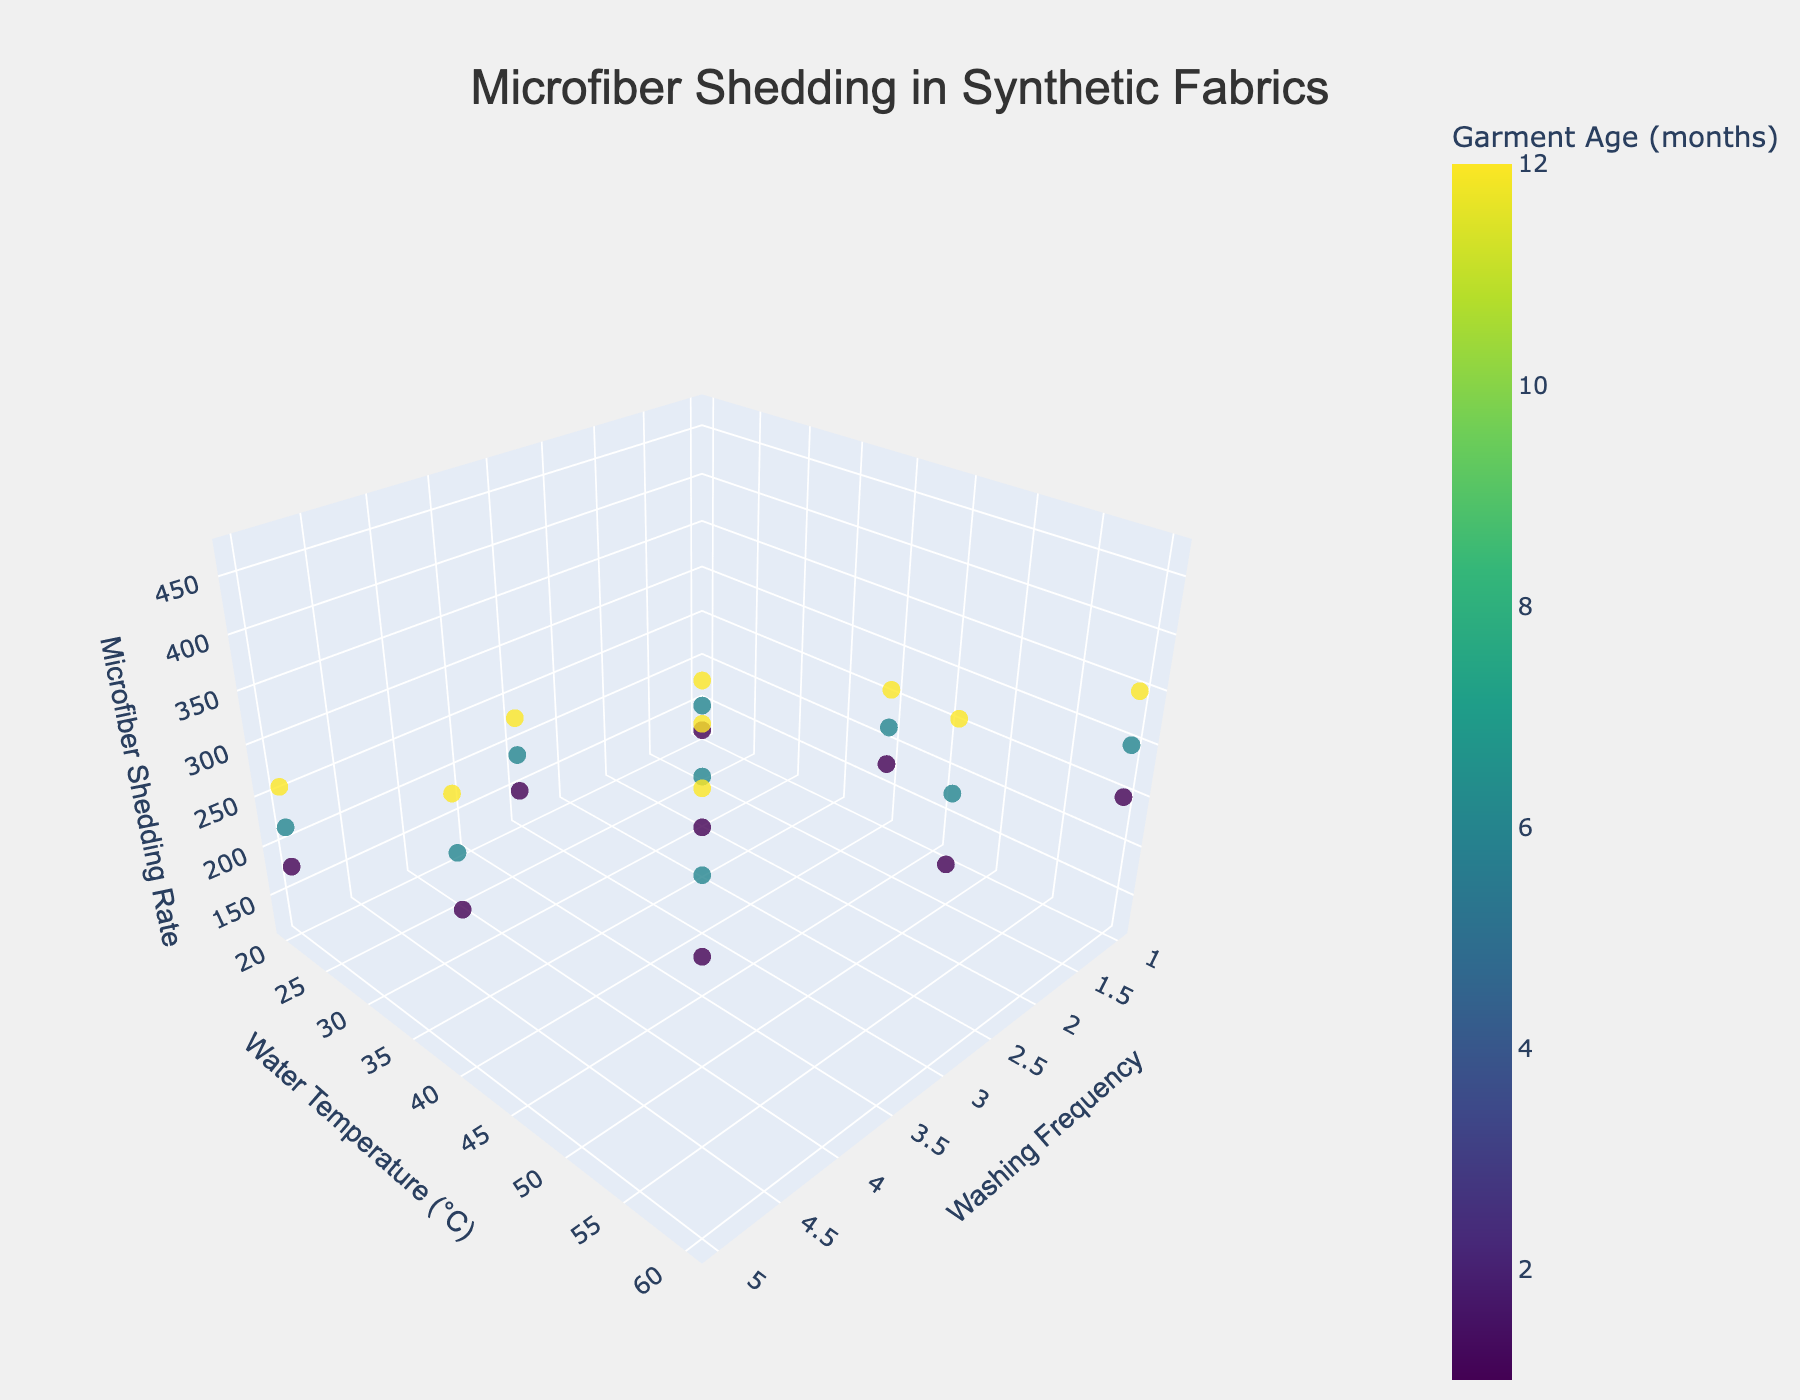What is the title of the figure? Look at the top center of the figure where the title is displayed.
Answer: Microfiber Shedding in Synthetic Fabrics What are the three variables plotted on each axis? The variables are labeled at the tips of the axes. The x-axis is washing frequency, the y-axis is water temperature, and the z-axis is microfiber shedding rate.
Answer: Washing frequency, Water temperature, Microfiber shedding rate How does microfiber shedding rate change with increasing washing frequency at a water temperature of 20°C for a 1-month-old garment? Look at the points along the line where the water temperature is 20°C and garment age is 1 month. Observe the z-values (microfiber shedding rate) at different washing frequencies.
Answer: Increases Which garment age has the highest microfiber shedding rate and what is that rate? Check the colorbar to find the color representing the highest microfiber shedding rate, then identify the corresponding garment age and shedding rate.
Answer: 12 months, 470 fibers How does the microfiber shedding rate for a washing frequency of 1 generally compare at different garment ages? Observe the points where the washing frequency is 1 and compare the z-values (microfiber shedding rates) across different garment ages.
Answer: Increases with garment age What is the difference in the microfiber shedding rate between garments washed at 60°C and 20°C after 3 washes when the garments are 6 months old? Identify the points for 3 washes at 60°C and 20°C with a garment age of 6 months, then compute the difference in their z-values (microfiber shedding rates).
Answer: 170 fibers (360 - 190) What is the average microfiber shedding rate for garments aged 12 months washed at a frequency of 5? Locate the points with washing frequency of 5 and garment age of 12 months, then average their z-values (microfiber shedding rates).
Answer: 363.33 fibers (sum of 260, 360, and 470 divided by 3) Do washing frequency and water temperature have a combined effect on microfiber shedding rates for garments of the same age? Observe the variation in z-values (microfiber shedding rates) across different washing frequencies and water temperatures for garments of the same age.
Answer: Yes What is the color scale used to visualize garment age? Look at the color bar on the right side of the figure that indicates the color scale used.
Answer: Viridis Which washing frequency and water temperature combination results in the highest microfiber shedding rate for garments aged 6 months? Find the point with the highest z-value (microfiber shedding rate) among the points where the garment age is 6 months. Note the corresponding washing frequency and water temperature.
Answer: 5 washes, 60°C 